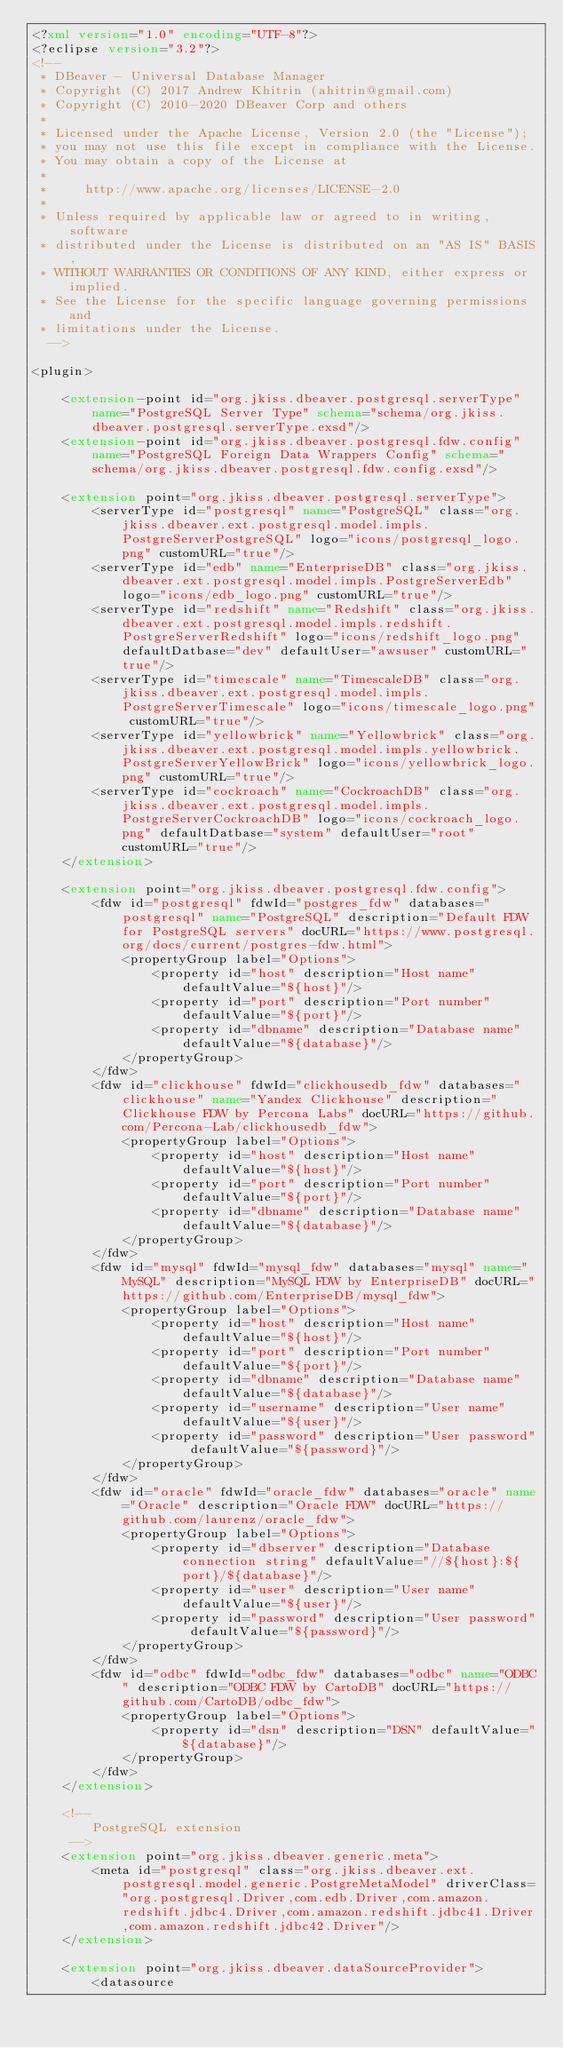<code> <loc_0><loc_0><loc_500><loc_500><_XML_><?xml version="1.0" encoding="UTF-8"?>
<?eclipse version="3.2"?>
<!--
 * DBeaver - Universal Database Manager
 * Copyright (C) 2017 Andrew Khitrin (ahitrin@gmail.com) 
 * Copyright (C) 2010-2020 DBeaver Corp and others
 *
 * Licensed under the Apache License, Version 2.0 (the "License");
 * you may not use this file except in compliance with the License.
 * You may obtain a copy of the License at
 *
 *     http://www.apache.org/licenses/LICENSE-2.0
 *
 * Unless required by applicable law or agreed to in writing, software
 * distributed under the License is distributed on an "AS IS" BASIS,
 * WITHOUT WARRANTIES OR CONDITIONS OF ANY KIND, either express or implied.
 * See the License for the specific language governing permissions and
 * limitations under the License.
  -->
  
<plugin>

    <extension-point id="org.jkiss.dbeaver.postgresql.serverType" name="PostgreSQL Server Type" schema="schema/org.jkiss.dbeaver.postgresql.serverType.exsd"/>
    <extension-point id="org.jkiss.dbeaver.postgresql.fdw.config" name="PostgreSQL Foreign Data Wrappers Config" schema="schema/org.jkiss.dbeaver.postgresql.fdw.config.exsd"/>

    <extension point="org.jkiss.dbeaver.postgresql.serverType">
        <serverType id="postgresql" name="PostgreSQL" class="org.jkiss.dbeaver.ext.postgresql.model.impls.PostgreServerPostgreSQL" logo="icons/postgresql_logo.png" customURL="true"/>
        <serverType id="edb" name="EnterpriseDB" class="org.jkiss.dbeaver.ext.postgresql.model.impls.PostgreServerEdb" logo="icons/edb_logo.png" customURL="true"/>
        <serverType id="redshift" name="Redshift" class="org.jkiss.dbeaver.ext.postgresql.model.impls.redshift.PostgreServerRedshift" logo="icons/redshift_logo.png" defaultDatbase="dev" defaultUser="awsuser" customURL="true"/>
        <serverType id="timescale" name="TimescaleDB" class="org.jkiss.dbeaver.ext.postgresql.model.impls.PostgreServerTimescale" logo="icons/timescale_logo.png" customURL="true"/>
        <serverType id="yellowbrick" name="Yellowbrick" class="org.jkiss.dbeaver.ext.postgresql.model.impls.yellowbrick.PostgreServerYellowBrick" logo="icons/yellowbrick_logo.png" customURL="true"/>
        <serverType id="cockroach" name="CockroachDB" class="org.jkiss.dbeaver.ext.postgresql.model.impls.PostgreServerCockroachDB" logo="icons/cockroach_logo.png" defaultDatbase="system" defaultUser="root" customURL="true"/>
    </extension>

    <extension point="org.jkiss.dbeaver.postgresql.fdw.config">
        <fdw id="postgresql" fdwId="postgres_fdw" databases="postgresql" name="PostgreSQL" description="Default FDW for PostgreSQL servers" docURL="https://www.postgresql.org/docs/current/postgres-fdw.html">
            <propertyGroup label="Options">
                <property id="host" description="Host name" defaultValue="${host}"/>
                <property id="port" description="Port number" defaultValue="${port}"/>
                <property id="dbname" description="Database name" defaultValue="${database}"/>
            </propertyGroup>
        </fdw>
        <fdw id="clickhouse" fdwId="clickhousedb_fdw" databases="clickhouse" name="Yandex Clickhouse" description="Clickhouse FDW by Percona Labs" docURL="https://github.com/Percona-Lab/clickhousedb_fdw">
            <propertyGroup label="Options">
                <property id="host" description="Host name" defaultValue="${host}"/>
                <property id="port" description="Port number" defaultValue="${port}"/>
                <property id="dbname" description="Database name" defaultValue="${database}"/>
            </propertyGroup>
        </fdw>
        <fdw id="mysql" fdwId="mysql_fdw" databases="mysql" name="MySQL" description="MySQL FDW by EnterpriseDB" docURL="https://github.com/EnterpriseDB/mysql_fdw">
            <propertyGroup label="Options">
                <property id="host" description="Host name" defaultValue="${host}"/>
                <property id="port" description="Port number" defaultValue="${port}"/>
                <property id="dbname" description="Database name" defaultValue="${database}"/>
                <property id="username" description="User name" defaultValue="${user}"/>
                <property id="password" description="User password" defaultValue="${password}"/>
            </propertyGroup>
        </fdw>
        <fdw id="oracle" fdwId="oracle_fdw" databases="oracle" name="Oracle" description="Oracle FDW" docURL="https://github.com/laurenz/oracle_fdw">
            <propertyGroup label="Options">
                <property id="dbserver" description="Database connection string" defaultValue="//${host}:${port}/${database}"/>
                <property id="user" description="User name" defaultValue="${user}"/>
                <property id="password" description="User password" defaultValue="${password}"/>
            </propertyGroup>
        </fdw>
        <fdw id="odbc" fdwId="odbc_fdw" databases="odbc" name="ODBC" description="ODBC FDW by CartoDB" docURL="https://github.com/CartoDB/odbc_fdw">
            <propertyGroup label="Options">
                <property id="dsn" description="DSN" defaultValue="${database}"/>
            </propertyGroup>
        </fdw>
    </extension>

    <!--
        PostgreSQL extension
     -->
    <extension point="org.jkiss.dbeaver.generic.meta">
        <meta id="postgresql" class="org.jkiss.dbeaver.ext.postgresql.model.generic.PostgreMetaModel" driverClass="org.postgresql.Driver,com.edb.Driver,com.amazon.redshift.jdbc4.Driver,com.amazon.redshift.jdbc41.Driver,com.amazon.redshift.jdbc42.Driver"/>
    </extension>

    <extension point="org.jkiss.dbeaver.dataSourceProvider">
        <datasource</code> 